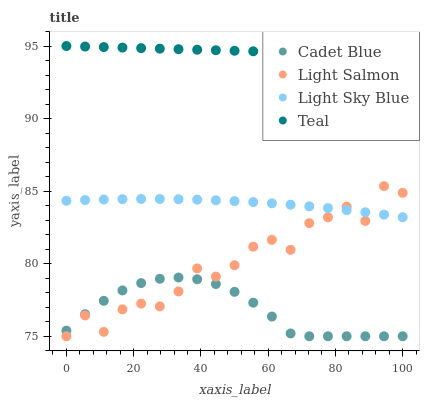Does Cadet Blue have the minimum area under the curve?
Answer yes or no. Yes. Does Teal have the maximum area under the curve?
Answer yes or no. Yes. Does Teal have the minimum area under the curve?
Answer yes or no. No. Does Cadet Blue have the maximum area under the curve?
Answer yes or no. No. Is Teal the smoothest?
Answer yes or no. Yes. Is Light Salmon the roughest?
Answer yes or no. Yes. Is Cadet Blue the smoothest?
Answer yes or no. No. Is Cadet Blue the roughest?
Answer yes or no. No. Does Light Salmon have the lowest value?
Answer yes or no. Yes. Does Teal have the lowest value?
Answer yes or no. No. Does Teal have the highest value?
Answer yes or no. Yes. Does Cadet Blue have the highest value?
Answer yes or no. No. Is Cadet Blue less than Light Sky Blue?
Answer yes or no. Yes. Is Light Sky Blue greater than Cadet Blue?
Answer yes or no. Yes. Does Light Sky Blue intersect Light Salmon?
Answer yes or no. Yes. Is Light Sky Blue less than Light Salmon?
Answer yes or no. No. Is Light Sky Blue greater than Light Salmon?
Answer yes or no. No. Does Cadet Blue intersect Light Sky Blue?
Answer yes or no. No. 